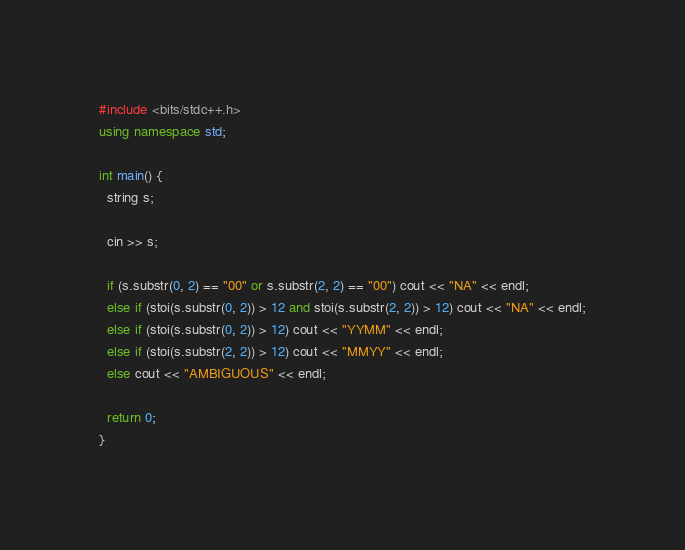<code> <loc_0><loc_0><loc_500><loc_500><_C++_>#include <bits/stdc++.h>
using namespace std;

int main() {
  string s;

  cin >> s;

  if (s.substr(0, 2) == "00" or s.substr(2, 2) == "00") cout << "NA" << endl;
  else if (stoi(s.substr(0, 2)) > 12 and stoi(s.substr(2, 2)) > 12) cout << "NA" << endl;
  else if (stoi(s.substr(0, 2)) > 12) cout << "YYMM" << endl;
  else if (stoi(s.substr(2, 2)) > 12) cout << "MMYY" << endl;
  else cout << "AMBIGUOUS" << endl;

  return 0;
}</code> 